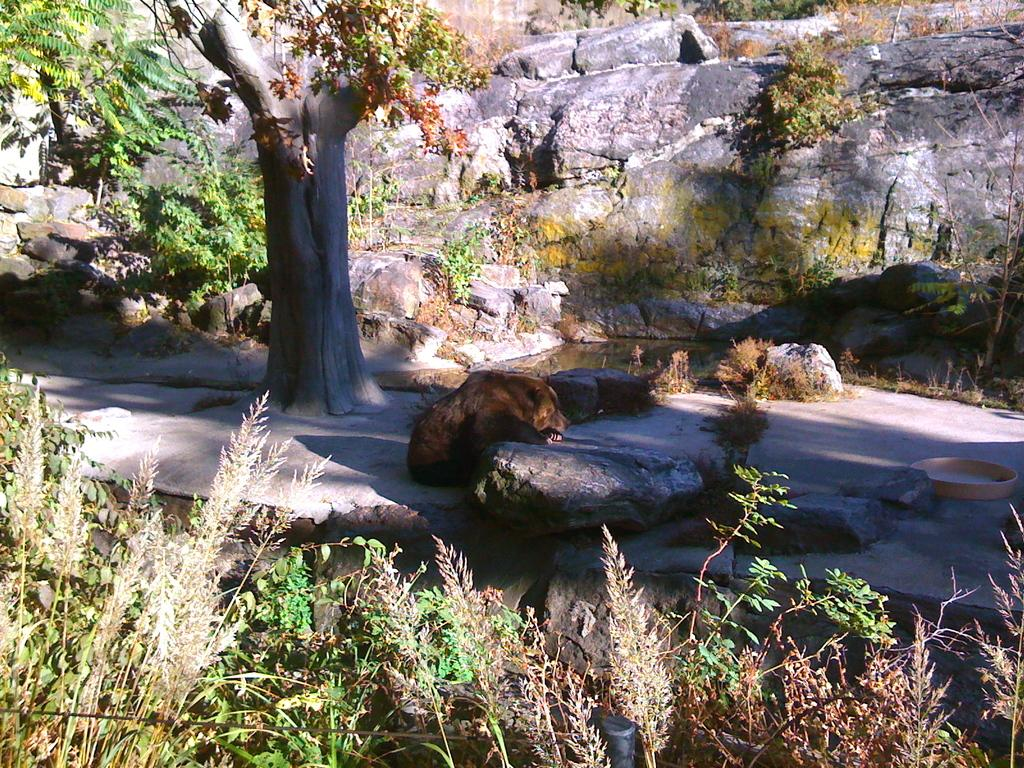What type of animal can be seen near a tree in the image? The image features an animal near a tree, but the specific type of animal is not mentioned in the facts. What is the purpose of the small pool with water in the image? The facts do not specify the purpose of the small pool with water in the image. What is the pole used for in the image? The facts do not provide information about the purpose of the pole in the image. What type of food is in the bowl in the image? The facts do not specify the type of food in the bowl in the image. How many trees are visible in the image? There are trees in the image, but the exact number is not mentioned in the facts. What type of plants are present in the image? The facts mention that there are plants in the image, but the specific type of plants is not specified. What is the purpose of the bushes in the image? The facts do not provide information about the purpose of the bushes in the image. What type of grass is in the image? The facts do not specify the type of grass in the image. Where is the judge located in the image? There is no judge present in the image. What is the purpose of the stop sign in the image? There is no stop sign present in the image. What type of pump is visible in the image? There is no pump present in the image. 